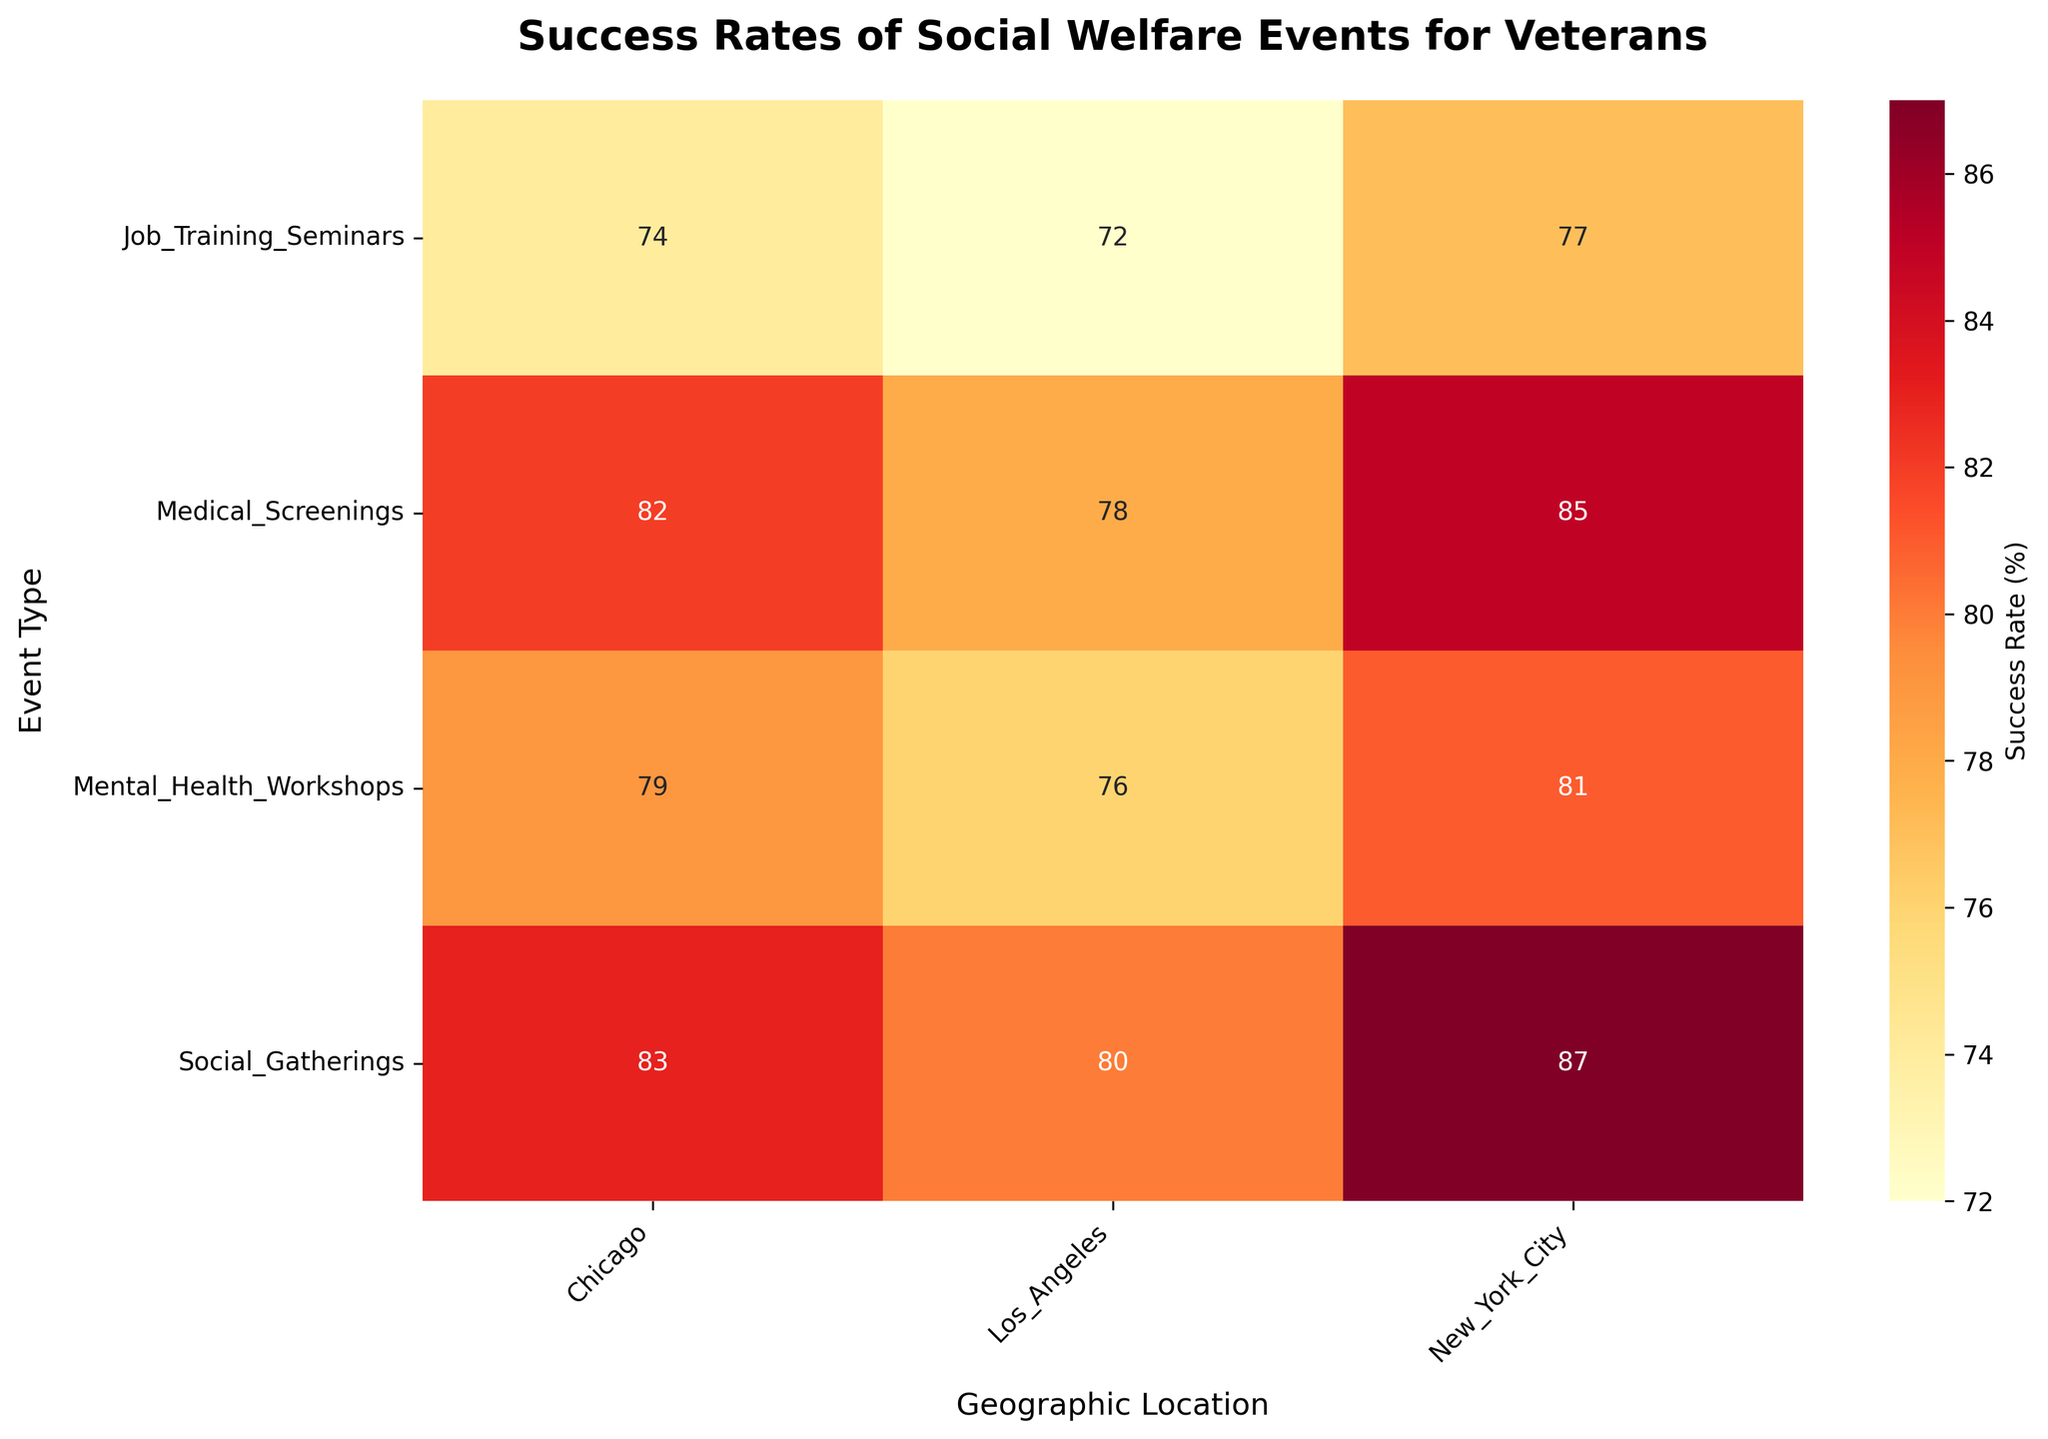What's the title of the heatmap? The title is normally displayed at the top of the figure. In this case, the title "Success Rates of Social Welfare Events for Veterans" is clearly indicated.
Answer: Success Rates of Social Welfare Events for Veterans Which Geographic Location has the highest success rate for Social Gatherings? By looking at the heatmap under the "Social Gatherings" row, we can see the highest value. New York City has the highest success rate for Social Gatherings with a value of 87.
Answer: New York City What is the difference in success rates between Job Training Seminars in Los Angeles and New York City? Locate the respective cells for Job Training Seminars in the rows and the locations in the columns. Subtract the success rate in Los Angeles (72) from the success rate in New York City (77). 77 - 72 = 5.
Answer: 5 Which Event Type has the lowest success rate in Chicago? By scanning the cells in the Chicago column, we find the lowest value. The lowest success rate for an event in Chicago is for Job Training Seminars, which has a value of 74.
Answer: Job Training Seminars How does the success rate for Medical Screenings in New York City compare to Social Gatherings in Los Angeles? Look at the success rates for both events and compare them. The success rate for Medical Screenings in New York City is 85, while it is 80 for Social Gatherings in Los Angeles. 85 is greater than 80.
Answer: Medical Screenings in New York City is higher What is the average success rate for Mental Health Workshops across all geographic locations? Sum the success rates for Mental Health Workshops (Los Angeles: 76, New York City: 81, Chicago: 79). Then divide by the number of locations (3). (76 + 81 + 79) / 3 = 78.67.
Answer: 78.67 In which Geographic Location do Social Gatherings have a higher success rate than Mental Health Workshops? Compare the success rates of Social Gatherings to Mental Health Workshops across the locations. Social Gatherings have a success rate higher than Mental Health Workshops in all locations: Los Angeles (80 > 76), New York City (87 > 81), Chicago (83 > 79).
Answer: Los Angeles, New York City, Chicago Which Event Type in Los Angeles has the second-highest success rate? Look at all the success rates for events in Los Angeles. The values are Medical Screenings (78), Mental Health Workshops (76), Job Training Seminars (72), and Social Gatherings (80). The second-highest value after 80 is 78.
Answer: Medical Screenings What is the overall highest success rate observed in the heatmap? Scan through all cells in the heatmap to identify the highest number. The highest value observed is for Social Gatherings in New York City with a success rate of 87.
Answer: 87 